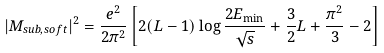Convert formula to latex. <formula><loc_0><loc_0><loc_500><loc_500>| M _ { s u b , s o f t } | ^ { 2 } = \frac { e ^ { 2 } } { 2 \pi ^ { 2 } } \left [ 2 ( L - 1 ) \log \frac { 2 E _ { \min } } { \sqrt { s } } + \frac { 3 } { 2 } L + \frac { \pi ^ { 2 } } { 3 } - 2 \right ]</formula> 